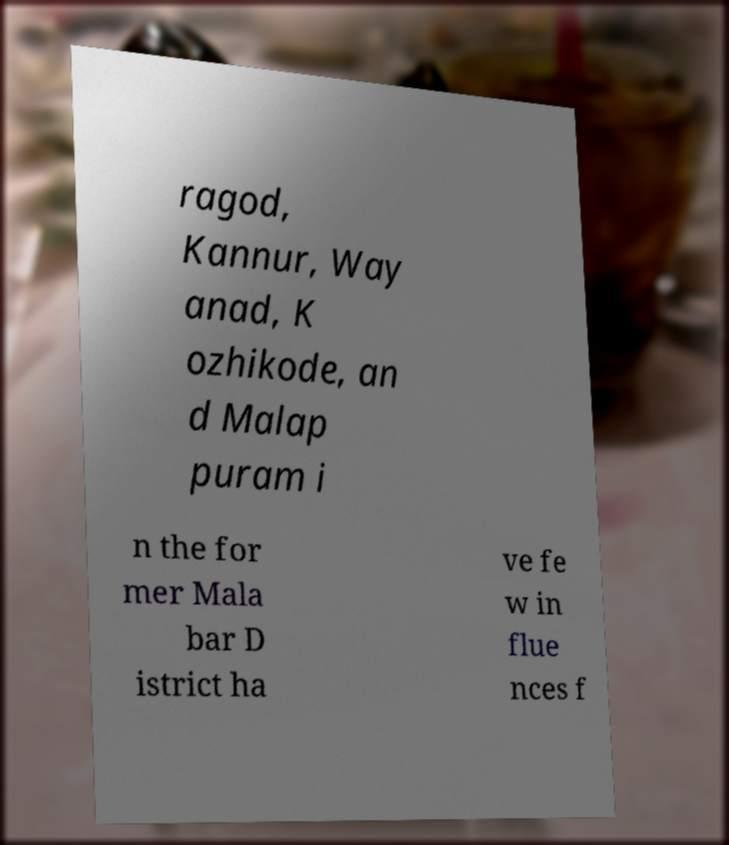There's text embedded in this image that I need extracted. Can you transcribe it verbatim? ragod, Kannur, Way anad, K ozhikode, an d Malap puram i n the for mer Mala bar D istrict ha ve fe w in flue nces f 